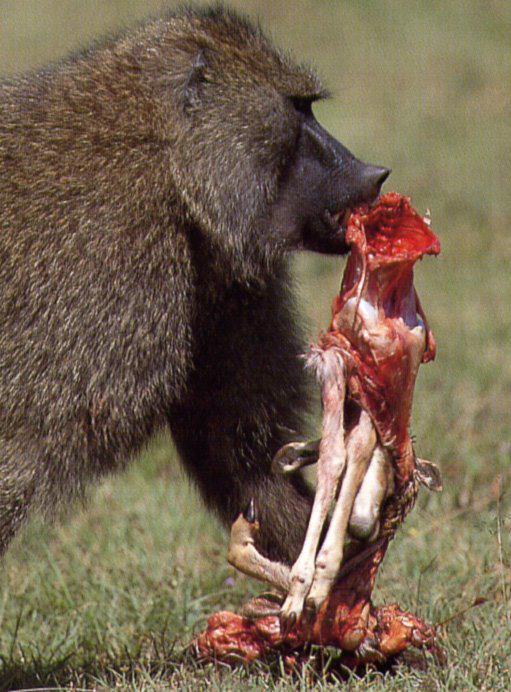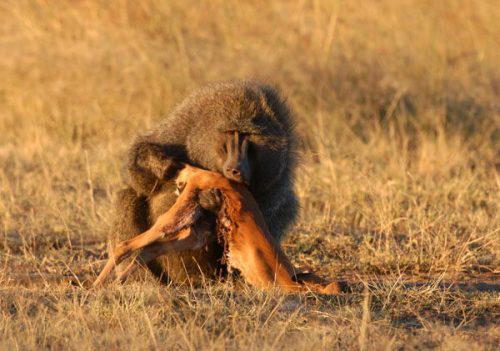The first image is the image on the left, the second image is the image on the right. Considering the images on both sides, is "There's at least one monkey eating an animal." valid? Answer yes or no. Yes. 